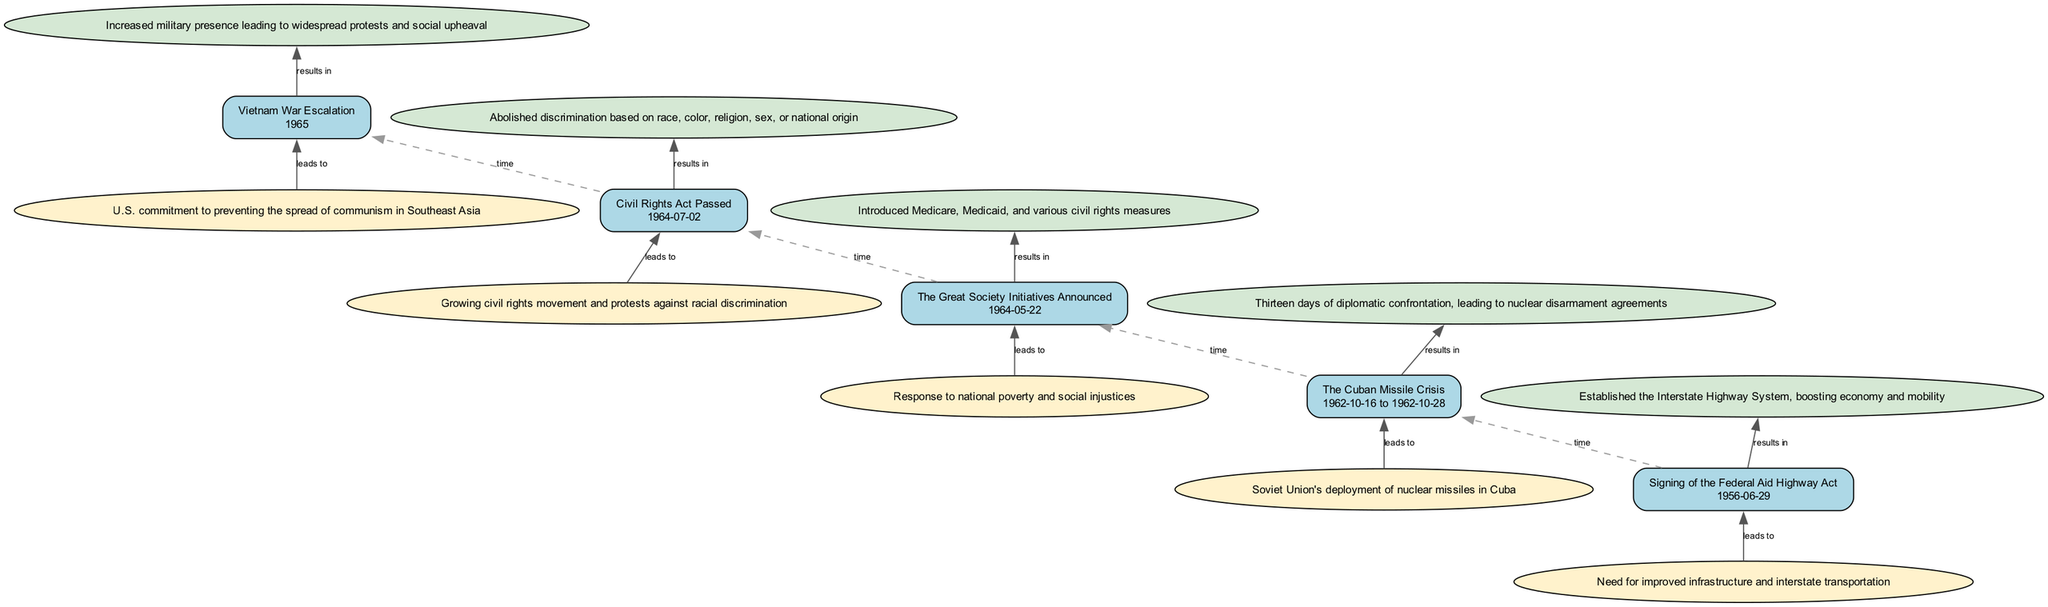What event occurred on July 2, 1964? The diagram clearly indicates that the "Civil Rights Act Passed" is the event listed on that specific date. The date node connected to the corresponding event node is labeled with "1964-07-02."
Answer: Civil Rights Act Passed What effect is associated with the signing of the Federal Aid Highway Act? The flow chart shows that the effect of the "Signing of the Federal Aid Highway Act" is "Established the Interstate Highway System, boosting economy and mobility" which is directly linked to this event node.
Answer: Established the Interstate Highway System, boosting economy and mobility How many major events are depicted in the diagram? By counting the individual event nodes represented in the flowchart, there are five separate events that are clearly outlined.
Answer: 5 What is the historical relevance of the Cuban Missile Crisis? The historical relevance stated in the diagram for the "Cuban Missile Crisis" is "Marked a peak of Cold War tensions and shaped future U.S. foreign policy." This information can be found in the tooltip associated with that event node.
Answer: Marked a peak of Cold War tensions and shaped future U.S. foreign policy What leads to the escalation of the Vietnam War? According to the diagram, the cause linked to the "Vietnam War Escalation" is "U.S. commitment to preventing the spread of communism in Southeast Asia," which clearly leads to this event node.
Answer: U.S. commitment to preventing the spread of communism in Southeast Asia What is the direct effect of the Great Society Initiatives Announced? The direct effect associated with "The Great Society Initiatives Announced" is "Introduced Medicare, Medicaid, and various civil rights measures," as noted in the flowing effect node connected to that event.
Answer: Introduced Medicare, Medicaid, and various civil rights measures Which event directly follows the signing of the Federal Aid Highway Act? The diagram indicates that the "Civil Rights Act Passed" is directly connected to the event node of the "Signing of the Federal Aid Highway Act" by a dashed edge labelled with "time," representing the chronological order of events.
Answer: Civil Rights Act Passed What outcome was a result of the Cuban Missile Crisis? The diagram specifies that the outcome of "The Cuban Missile Crisis" is "Thirteen days of diplomatic confrontation, leading to nuclear disarmament agreements," which is linked to the corresponding effect node of this event.
Answer: Thirteen days of diplomatic confrontation, leading to nuclear disarmament agreements Which event highlights the response to national poverty? The "Great Society Initiatives Announced" event is distinctly described as a response to national poverty and social injustices based on the cause connecting to it in the diagram.
Answer: Great Society Initiatives Announced 